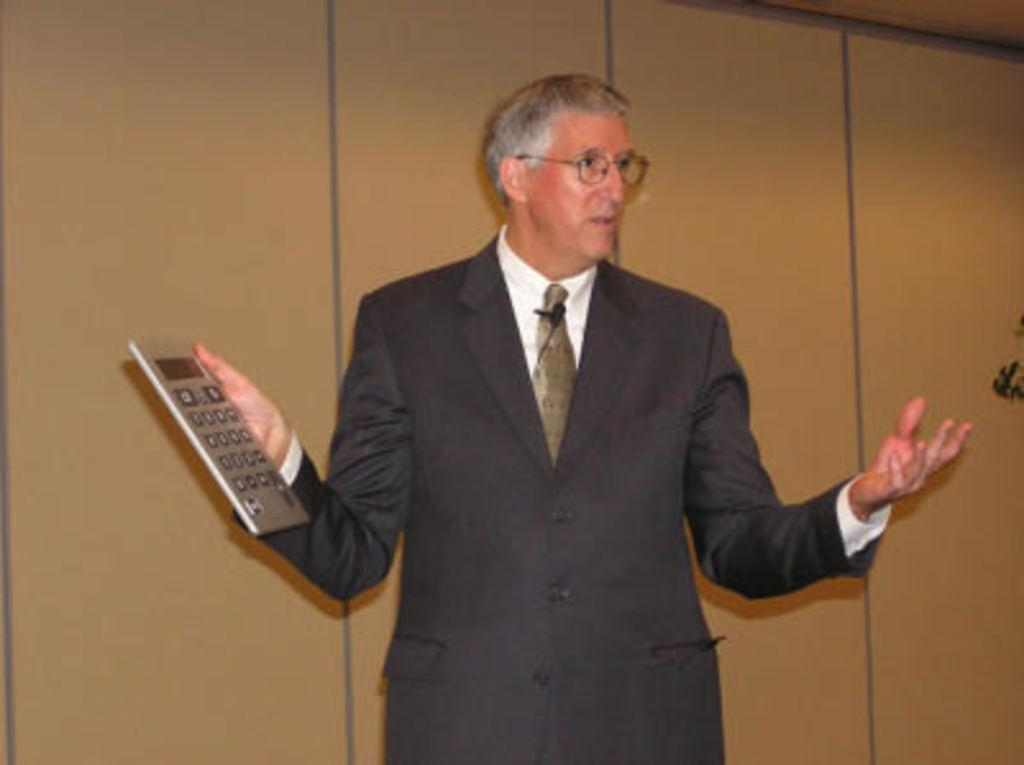Who is the main subject in the picture? There is a person in the center of the picture. What is the person wearing? The person is wearing a black suit. What object is the person holding? The person is holding a calculator. What can be seen behind the person? There is a wall visible behind the person. What book is the person reading in the image? There is no book present in the image; the person is holding a calculator. What caption can be seen at the bottom of the image? There is no caption visible at the bottom of the image. 